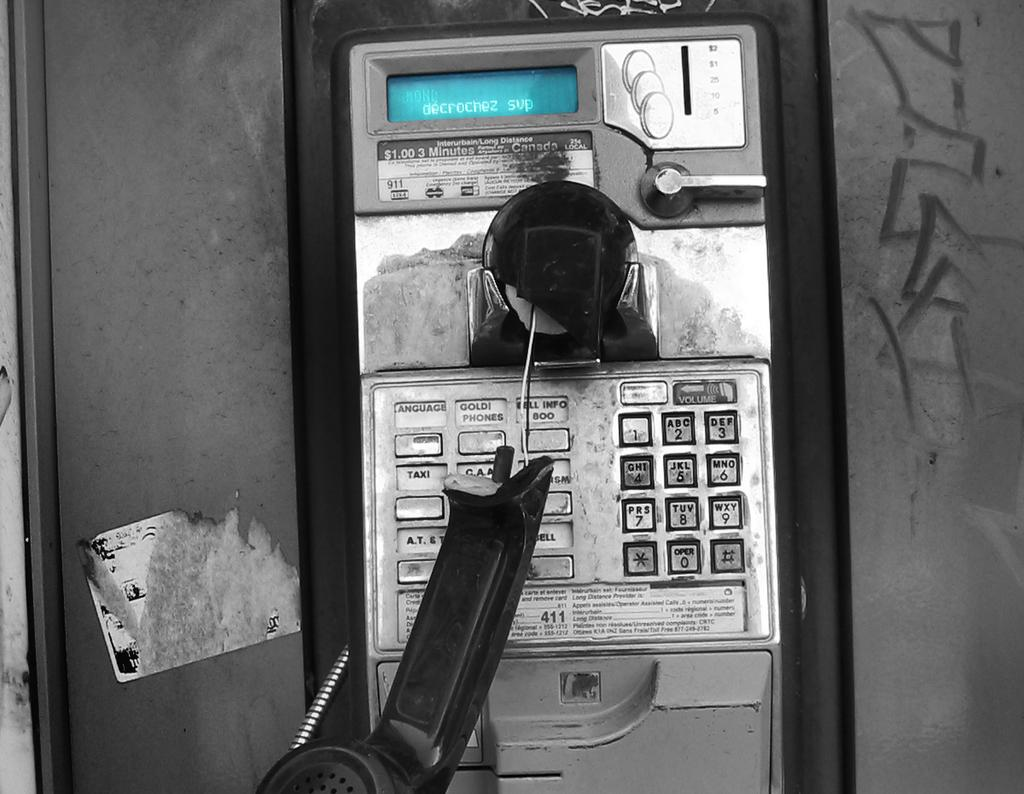<image>
Offer a succinct explanation of the picture presented. A payphone is broken in half and the screen says decrochez sup. 